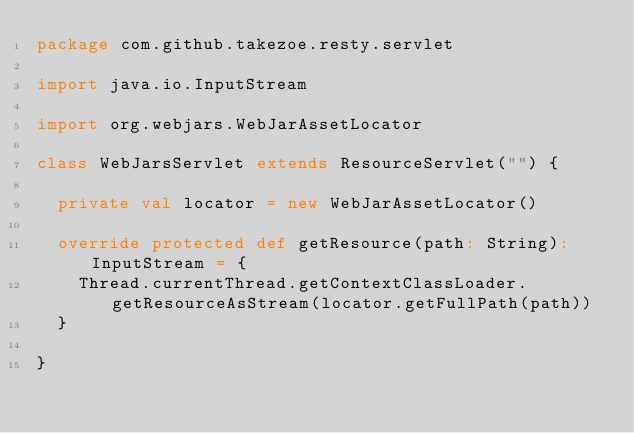<code> <loc_0><loc_0><loc_500><loc_500><_Scala_>package com.github.takezoe.resty.servlet

import java.io.InputStream

import org.webjars.WebJarAssetLocator

class WebJarsServlet extends ResourceServlet("") {

  private val locator = new WebJarAssetLocator()

  override protected def getResource(path: String): InputStream = {
    Thread.currentThread.getContextClassLoader.getResourceAsStream(locator.getFullPath(path))
  }

}
</code> 